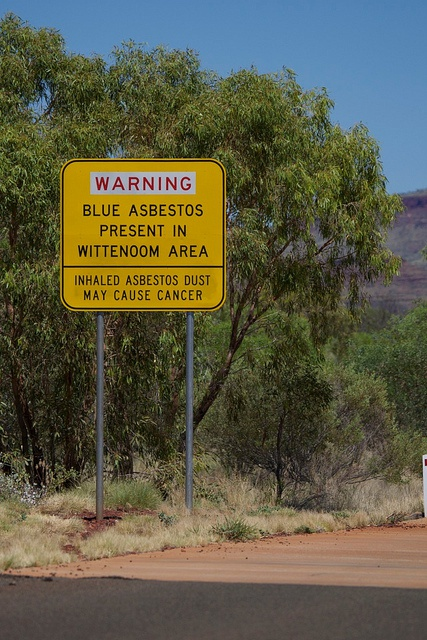Describe the objects in this image and their specific colors. I can see various objects in this image with different colors. 